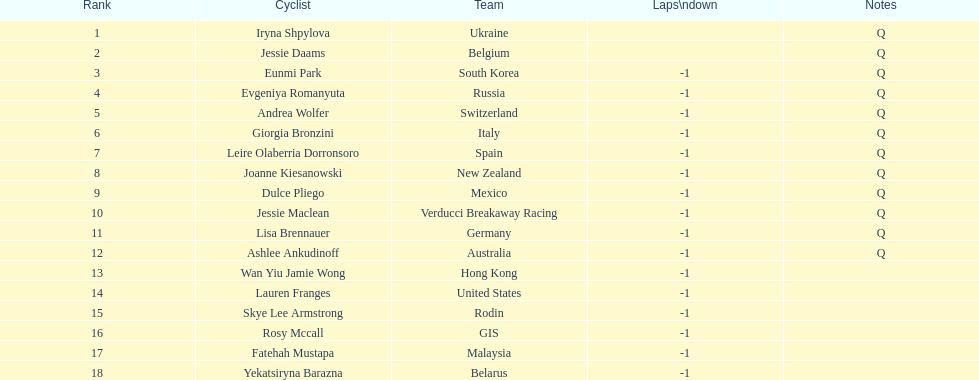Which two bicyclists belong to teams with no laps behind? Iryna Shpylova, Jessie Daams. 